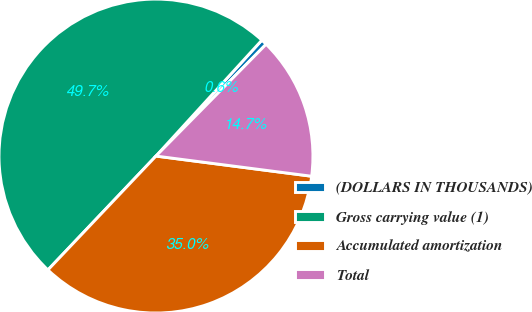Convert chart. <chart><loc_0><loc_0><loc_500><loc_500><pie_chart><fcel>(DOLLARS IN THOUSANDS)<fcel>Gross carrying value (1)<fcel>Accumulated amortization<fcel>Total<nl><fcel>0.6%<fcel>49.7%<fcel>35.03%<fcel>14.67%<nl></chart> 